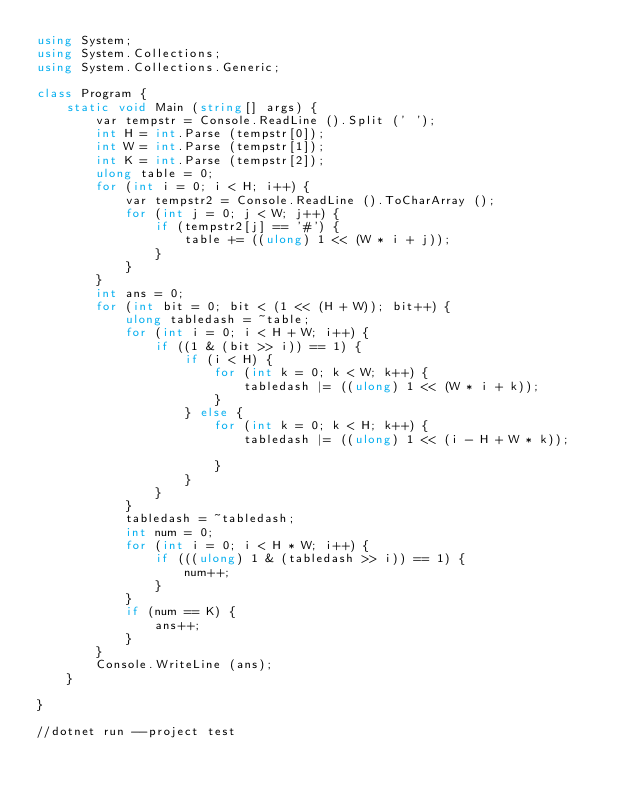<code> <loc_0><loc_0><loc_500><loc_500><_C#_>using System;
using System.Collections;
using System.Collections.Generic;

class Program {
    static void Main (string[] args) {
        var tempstr = Console.ReadLine ().Split (' ');
        int H = int.Parse (tempstr[0]);
        int W = int.Parse (tempstr[1]);
        int K = int.Parse (tempstr[2]);
        ulong table = 0;
        for (int i = 0; i < H; i++) {
            var tempstr2 = Console.ReadLine ().ToCharArray ();
            for (int j = 0; j < W; j++) {
                if (tempstr2[j] == '#') {
                    table += ((ulong) 1 << (W * i + j));
                }
            }
        }
        int ans = 0;
        for (int bit = 0; bit < (1 << (H + W)); bit++) {
            ulong tabledash = ~table;
            for (int i = 0; i < H + W; i++) {
                if ((1 & (bit >> i)) == 1) {
                    if (i < H) {
                        for (int k = 0; k < W; k++) {
                            tabledash |= ((ulong) 1 << (W * i + k));
                        }
                    } else {
                        for (int k = 0; k < H; k++) {
                            tabledash |= ((ulong) 1 << (i - H + W * k));

                        }
                    }
                }
            }
            tabledash = ~tabledash;
            int num = 0;
            for (int i = 0; i < H * W; i++) {
                if (((ulong) 1 & (tabledash >> i)) == 1) {
                    num++;
                }
            }
            if (num == K) {
                ans++;
            }
        }
        Console.WriteLine (ans);
    }

}

//dotnet run --project test</code> 